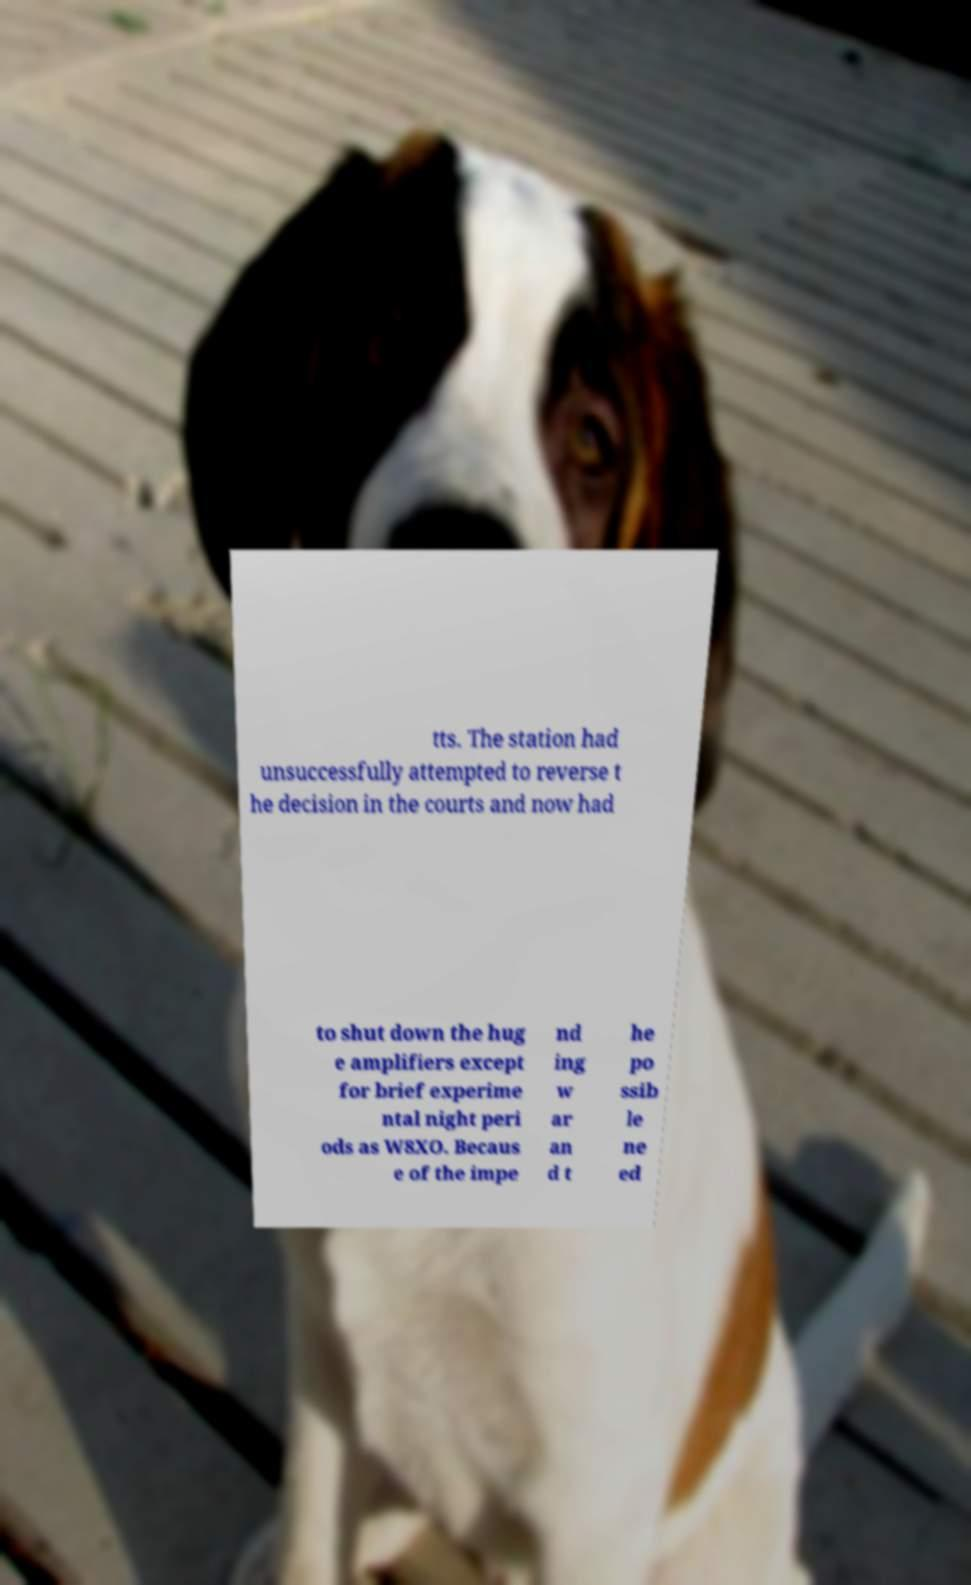For documentation purposes, I need the text within this image transcribed. Could you provide that? tts. The station had unsuccessfully attempted to reverse t he decision in the courts and now had to shut down the hug e amplifiers except for brief experime ntal night peri ods as W8XO. Becaus e of the impe nd ing w ar an d t he po ssib le ne ed 